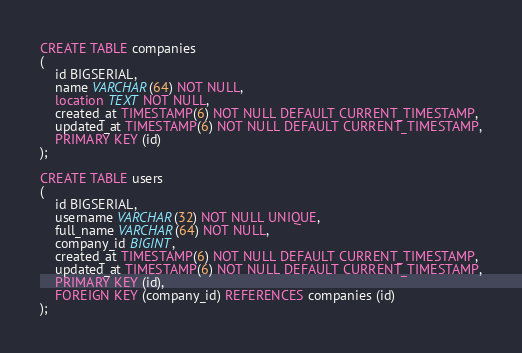Convert code to text. <code><loc_0><loc_0><loc_500><loc_500><_SQL_>CREATE TABLE companies
(
    id BIGSERIAL,
    name VARCHAR(64) NOT NULL,
    location TEXT NOT NULL,
    created_at TIMESTAMP(6) NOT NULL DEFAULT CURRENT_TIMESTAMP,
    updated_at TIMESTAMP(6) NOT NULL DEFAULT CURRENT_TIMESTAMP,
    PRIMARY KEY (id)
);

CREATE TABLE users
(
    id BIGSERIAL,
    username VARCHAR(32) NOT NULL UNIQUE,
    full_name VARCHAR(64) NOT NULL,
    company_id BIGINT,
    created_at TIMESTAMP(6) NOT NULL DEFAULT CURRENT_TIMESTAMP,
    updated_at TIMESTAMP(6) NOT NULL DEFAULT CURRENT_TIMESTAMP,
    PRIMARY KEY (id),
    FOREIGN KEY (company_id) REFERENCES companies (id)
);
</code> 